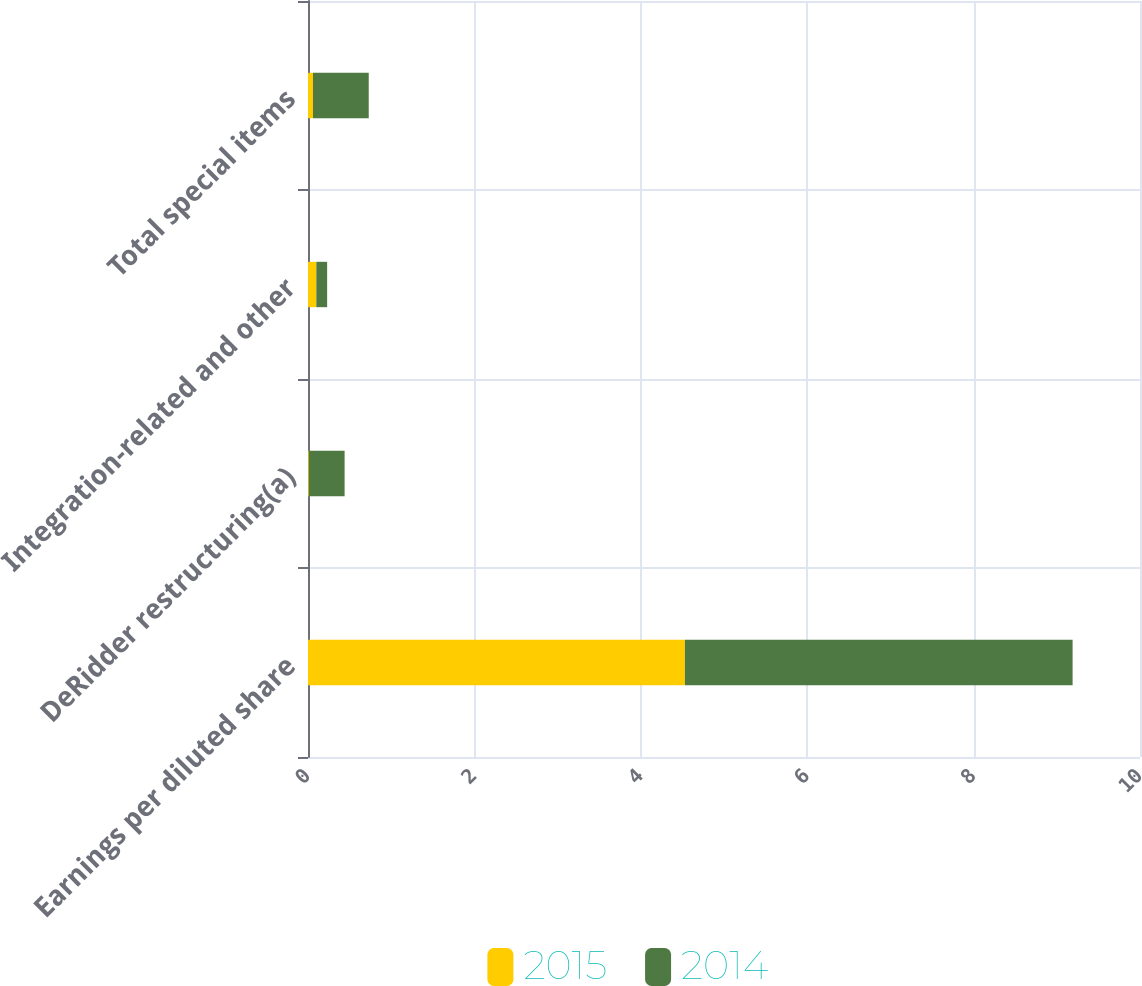Convert chart to OTSL. <chart><loc_0><loc_0><loc_500><loc_500><stacked_bar_chart><ecel><fcel>Earnings per diluted share<fcel>DeRidder restructuring(a)<fcel>Integration-related and other<fcel>Total special items<nl><fcel>2015<fcel>4.53<fcel>0.01<fcel>0.1<fcel>0.06<nl><fcel>2014<fcel>4.66<fcel>0.43<fcel>0.13<fcel>0.67<nl></chart> 